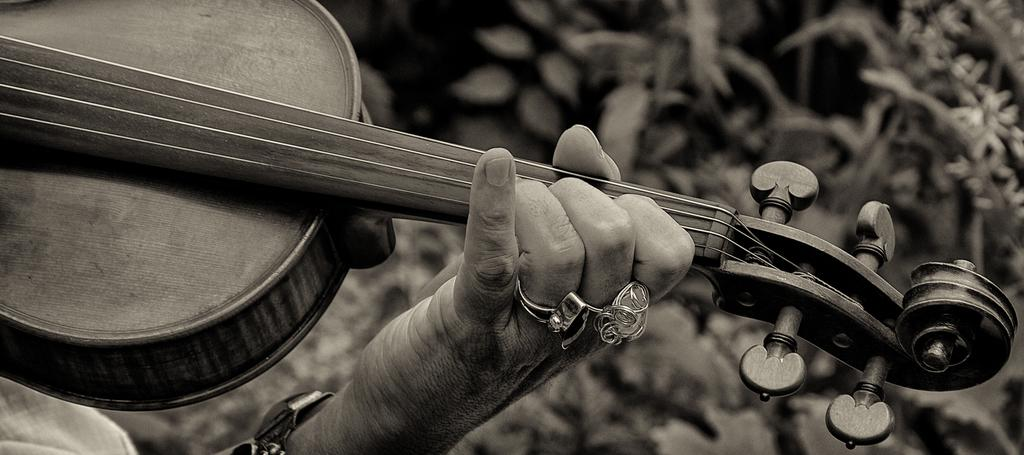What object can be seen in the picture that is related to music? There is a musical instrument in the picture. Can you describe any human presence in the image? Yes, there is a hand of a person visible in the picture. What type of creature is using the plough in the image? There is no plough or creature present in the image. 